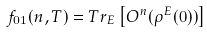Convert formula to latex. <formula><loc_0><loc_0><loc_500><loc_500>f _ { 0 1 } ( n , T ) = T r _ { E } \left [ O ^ { n } ( \rho ^ { E } ( 0 ) ) \right ]</formula> 